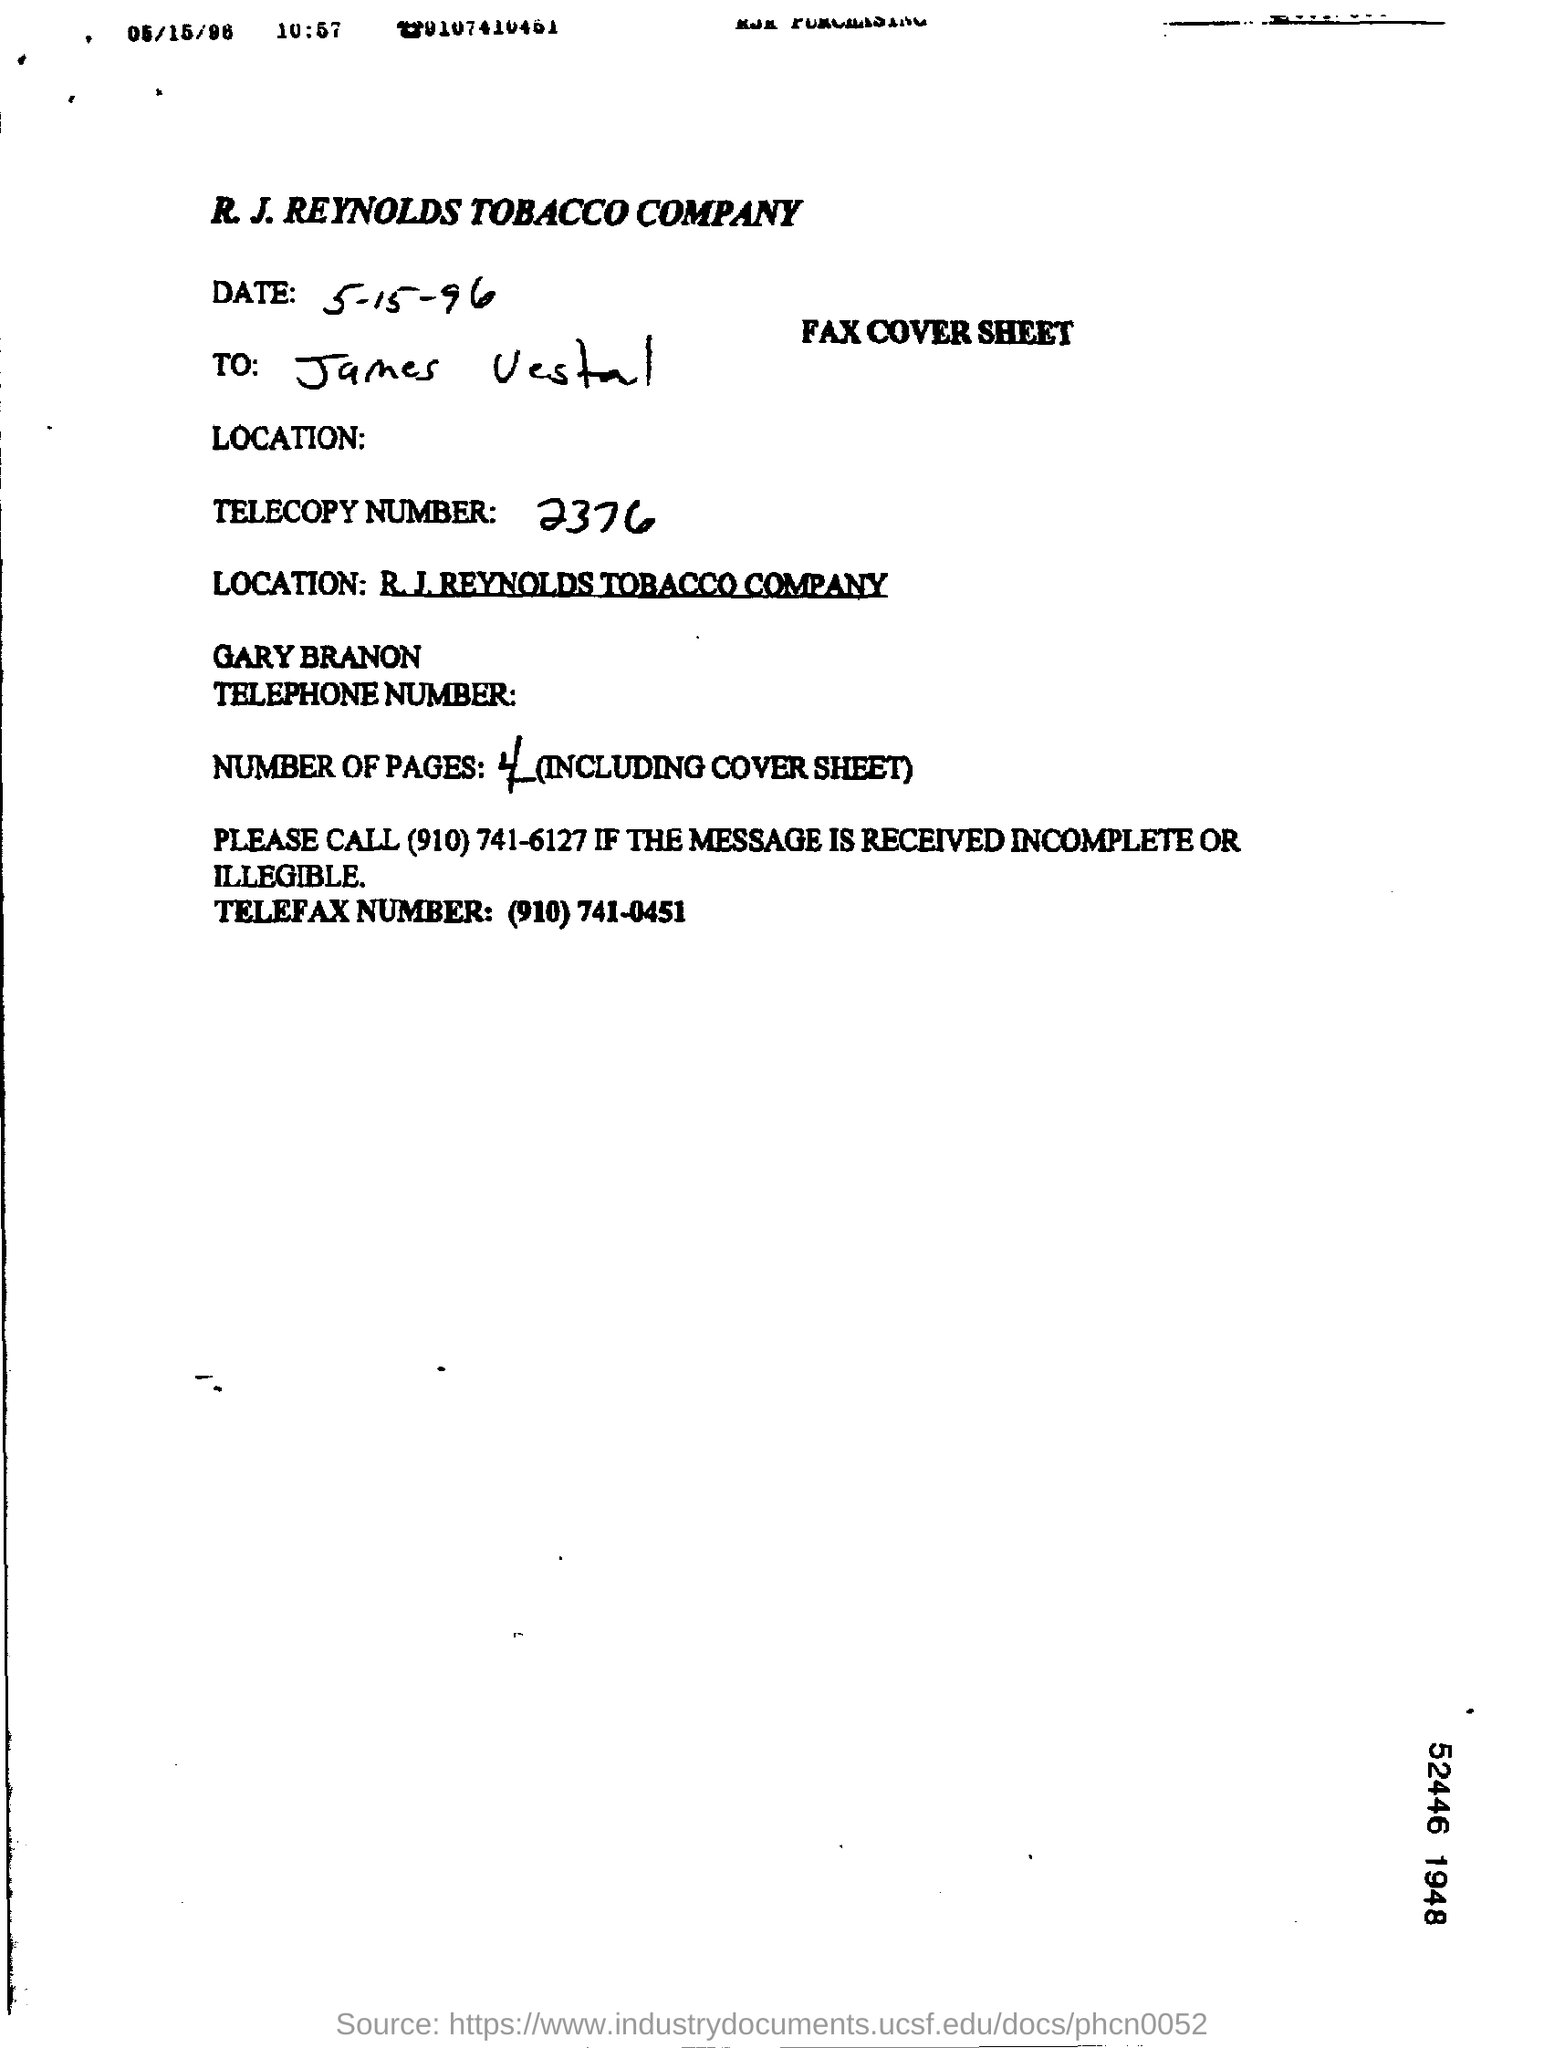Indicate a few pertinent items in this graphic. The date mentioned is 5-15-96. 